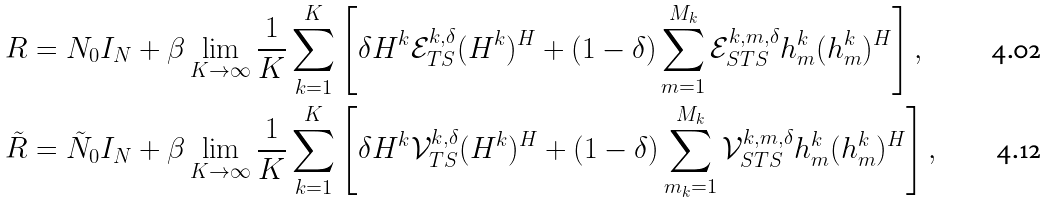Convert formula to latex. <formula><loc_0><loc_0><loc_500><loc_500>& R = N _ { 0 } I _ { N } + \beta \lim _ { K \rightarrow \infty } \frac { 1 } { K } \sum _ { k = 1 } ^ { K } \left [ \delta H ^ { k } \mathcal { E } _ { T S } ^ { k , \delta } ( H ^ { k } ) ^ { H } + ( 1 - \delta ) \sum _ { m = 1 } ^ { M _ { k } } \mathcal { E } _ { S T S } ^ { k , m , \delta } h _ { m } ^ { k } ( h _ { m } ^ { k } ) ^ { H } \right ] , \\ & \tilde { R } = \tilde { N } _ { 0 } I _ { N } + \beta \lim _ { K \rightarrow \infty } \frac { 1 } { K } \sum _ { k = 1 } ^ { K } \left [ \delta H ^ { k } \mathcal { V } _ { T S } ^ { k , \delta } ( H ^ { k } ) ^ { H } + ( 1 - \delta ) \sum _ { m _ { k } = 1 } ^ { M _ { k } } \mathcal { V } _ { S T S } ^ { k , m , \delta } h _ { m } ^ { k } ( h _ { m } ^ { k } ) ^ { H } \right ] ,</formula> 